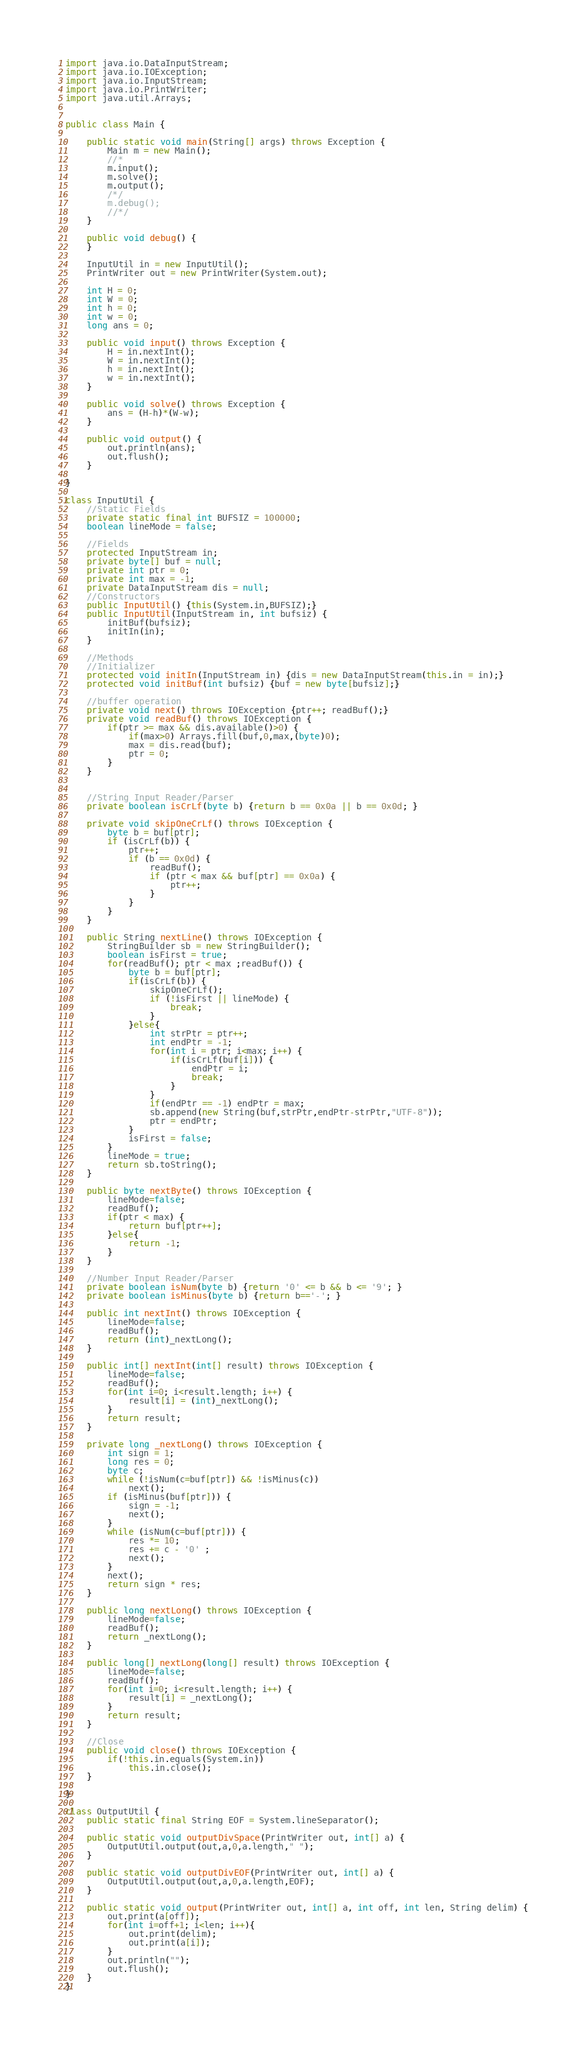Convert code to text. <code><loc_0><loc_0><loc_500><loc_500><_Java_>import java.io.DataInputStream;
import java.io.IOException;
import java.io.InputStream;
import java.io.PrintWriter;
import java.util.Arrays;


public class Main {
	
	public static void main(String[] args) throws Exception {
		Main m = new Main();
		//*
		m.input();
		m.solve();
		m.output();
		/*/
		m.debug();
		//*/
	}
	
	public void debug() {
	}
	
	InputUtil in = new InputUtil();
	PrintWriter out = new PrintWriter(System.out);
	
	int H = 0;
	int W = 0;
	int h = 0;
	int w = 0;
	long ans = 0;
			
	public void input() throws Exception {
		H = in.nextInt();
		W = in.nextInt();
		h = in.nextInt();
		w = in.nextInt();
	}
	
	public void solve() throws Exception {
		ans = (H-h)*(W-w);
	}
	
	public void output() {
		out.println(ans);
		out.flush();
	}
	
}

class InputUtil {
	//Static Fields
	private static final int BUFSIZ = 100000;
	boolean lineMode = false;
	
	//Fields
	protected InputStream in;
	private byte[] buf = null;
	private int ptr = 0;
	private int max = -1;
	private DataInputStream dis = null;
	//Constructors
	public InputUtil() {this(System.in,BUFSIZ);}
	public InputUtil(InputStream in, int bufsiz) {
		initBuf(bufsiz);
		initIn(in);
	}
	
	//Methods
	//Initializer
	protected void initIn(InputStream in) {dis = new DataInputStream(this.in = in);}
	protected void initBuf(int bufsiz) {buf = new byte[bufsiz];}
	
	//buffer operation
	private void next() throws IOException {ptr++; readBuf();}
	private void readBuf() throws IOException {
		if(ptr >= max && dis.available()>0) {
			if(max>0) Arrays.fill(buf,0,max,(byte)0);
			max = dis.read(buf);
			ptr = 0;
		}
	}
	
	
	//String Input Reader/Parser
	private boolean isCrLf(byte b) {return b == 0x0a || b == 0x0d; }
	
	private void skipOneCrLf() throws IOException {
		byte b = buf[ptr];
		if (isCrLf(b)) {
			ptr++;
			if (b == 0x0d) {
				readBuf();
				if (ptr < max && buf[ptr] == 0x0a) {
					ptr++;
				}
			}
		}
	}
	
	public String nextLine() throws IOException {
		StringBuilder sb = new StringBuilder();
		boolean isFirst = true;
		for(readBuf(); ptr < max ;readBuf()) {
			byte b = buf[ptr];
			if(isCrLf(b)) {
				skipOneCrLf();
				if (!isFirst || lineMode) {
					break;
				}
			}else{
				int strPtr = ptr++;
				int endPtr = -1;
				for(int i = ptr; i<max; i++) {
					if(isCrLf(buf[i])) {
						endPtr = i;
						break;
					}
				}
				if(endPtr == -1) endPtr = max;
				sb.append(new String(buf,strPtr,endPtr-strPtr,"UTF-8"));
				ptr = endPtr;
			}
			isFirst = false;
		}
		lineMode = true;
		return sb.toString();
	}
	
	public byte nextByte() throws IOException {
		lineMode=false;
		readBuf();
		if(ptr < max) {
			return buf[ptr++];
		}else{
			return -1;
		}
	}
	
	//Number Input Reader/Parser
	private boolean isNum(byte b) {return '0' <= b && b <= '9'; }
	private boolean isMinus(byte b) {return b=='-'; }
	
	public int nextInt() throws IOException {
		lineMode=false;
		readBuf();
		return (int)_nextLong();
	}
	
	public int[] nextInt(int[] result) throws IOException {
		lineMode=false;
		readBuf();
		for(int i=0; i<result.length; i++) {
			result[i] = (int)_nextLong();
		}
		return result;
	}
	
	private long _nextLong() throws IOException {
		int sign = 1;
		long res = 0;
		byte c;
		while (!isNum(c=buf[ptr]) && !isMinus(c)) 
			next();
		if (isMinus(buf[ptr])) {
			sign = -1;
			next();
		}
		while (isNum(c=buf[ptr])) {
			res *= 10;
			res += c - '0' ;
			next();
		}
		next();
		return sign * res;
	}
	
	public long nextLong() throws IOException {
		lineMode=false;
		readBuf();
		return _nextLong();
	}
	
	public long[] nextLong(long[] result) throws IOException {
		lineMode=false;
		readBuf();
		for(int i=0; i<result.length; i++) {
			result[i] = _nextLong();
		}
		return result;
	}
	
	//Close 
	public void close() throws IOException {
		if(!this.in.equals(System.in)) 
			this.in.close();
	}

}

class OutputUtil {
	public static final String EOF = System.lineSeparator();

	public static void outputDivSpace(PrintWriter out, int[] a) {
		OutputUtil.output(out,a,0,a.length," ");
	}
	
	public static void outputDivEOF(PrintWriter out, int[] a) {
		OutputUtil.output(out,a,0,a.length,EOF);
	}
	
	public static void output(PrintWriter out, int[] a, int off, int len, String delim) {
		out.print(a[off]);
		for(int i=off+1; i<len; i++){
			out.print(delim);
			out.print(a[i]);
		}
		out.println("");
		out.flush();
	}
}
</code> 